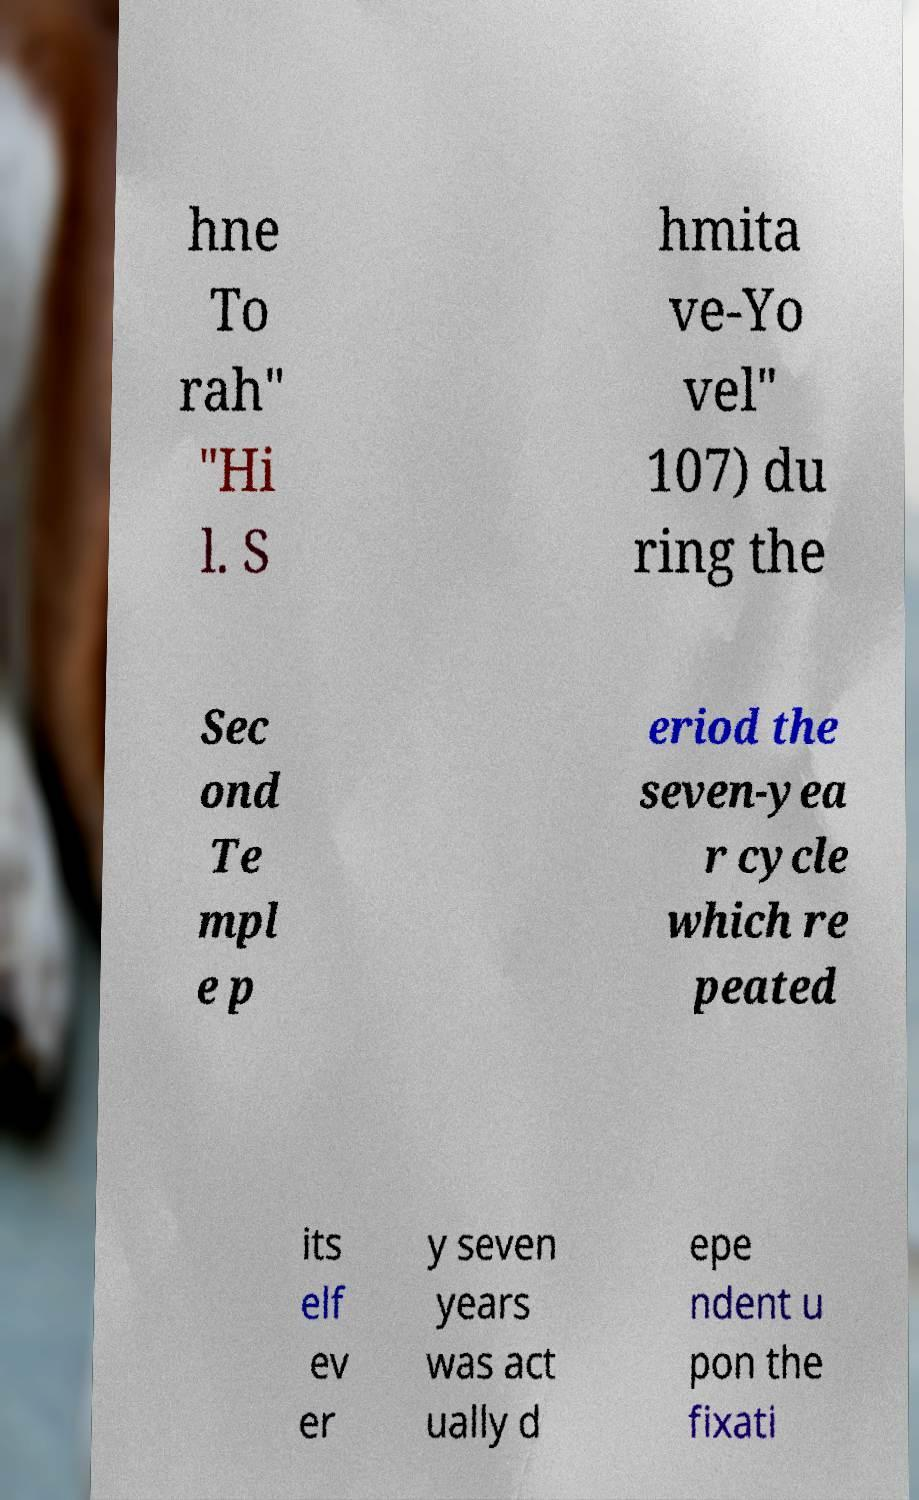Can you read and provide the text displayed in the image?This photo seems to have some interesting text. Can you extract and type it out for me? hne To rah" "Hi l. S hmita ve-Yo vel" 107) du ring the Sec ond Te mpl e p eriod the seven-yea r cycle which re peated its elf ev er y seven years was act ually d epe ndent u pon the fixati 